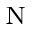<formula> <loc_0><loc_0><loc_500><loc_500>_ { N }</formula> 